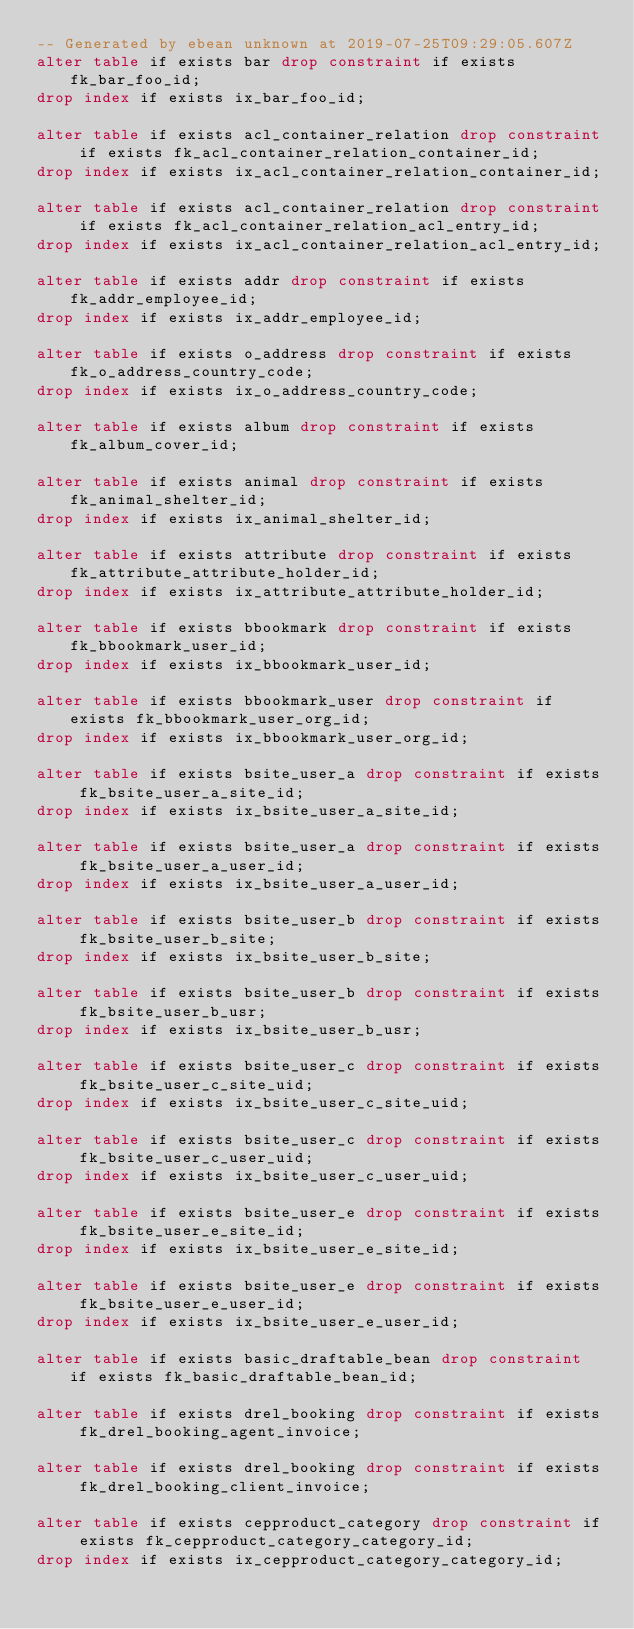<code> <loc_0><loc_0><loc_500><loc_500><_SQL_>-- Generated by ebean unknown at 2019-07-25T09:29:05.607Z
alter table if exists bar drop constraint if exists fk_bar_foo_id;
drop index if exists ix_bar_foo_id;

alter table if exists acl_container_relation drop constraint if exists fk_acl_container_relation_container_id;
drop index if exists ix_acl_container_relation_container_id;

alter table if exists acl_container_relation drop constraint if exists fk_acl_container_relation_acl_entry_id;
drop index if exists ix_acl_container_relation_acl_entry_id;

alter table if exists addr drop constraint if exists fk_addr_employee_id;
drop index if exists ix_addr_employee_id;

alter table if exists o_address drop constraint if exists fk_o_address_country_code;
drop index if exists ix_o_address_country_code;

alter table if exists album drop constraint if exists fk_album_cover_id;

alter table if exists animal drop constraint if exists fk_animal_shelter_id;
drop index if exists ix_animal_shelter_id;

alter table if exists attribute drop constraint if exists fk_attribute_attribute_holder_id;
drop index if exists ix_attribute_attribute_holder_id;

alter table if exists bbookmark drop constraint if exists fk_bbookmark_user_id;
drop index if exists ix_bbookmark_user_id;

alter table if exists bbookmark_user drop constraint if exists fk_bbookmark_user_org_id;
drop index if exists ix_bbookmark_user_org_id;

alter table if exists bsite_user_a drop constraint if exists fk_bsite_user_a_site_id;
drop index if exists ix_bsite_user_a_site_id;

alter table if exists bsite_user_a drop constraint if exists fk_bsite_user_a_user_id;
drop index if exists ix_bsite_user_a_user_id;

alter table if exists bsite_user_b drop constraint if exists fk_bsite_user_b_site;
drop index if exists ix_bsite_user_b_site;

alter table if exists bsite_user_b drop constraint if exists fk_bsite_user_b_usr;
drop index if exists ix_bsite_user_b_usr;

alter table if exists bsite_user_c drop constraint if exists fk_bsite_user_c_site_uid;
drop index if exists ix_bsite_user_c_site_uid;

alter table if exists bsite_user_c drop constraint if exists fk_bsite_user_c_user_uid;
drop index if exists ix_bsite_user_c_user_uid;

alter table if exists bsite_user_e drop constraint if exists fk_bsite_user_e_site_id;
drop index if exists ix_bsite_user_e_site_id;

alter table if exists bsite_user_e drop constraint if exists fk_bsite_user_e_user_id;
drop index if exists ix_bsite_user_e_user_id;

alter table if exists basic_draftable_bean drop constraint if exists fk_basic_draftable_bean_id;

alter table if exists drel_booking drop constraint if exists fk_drel_booking_agent_invoice;

alter table if exists drel_booking drop constraint if exists fk_drel_booking_client_invoice;

alter table if exists cepproduct_category drop constraint if exists fk_cepproduct_category_category_id;
drop index if exists ix_cepproduct_category_category_id;
</code> 